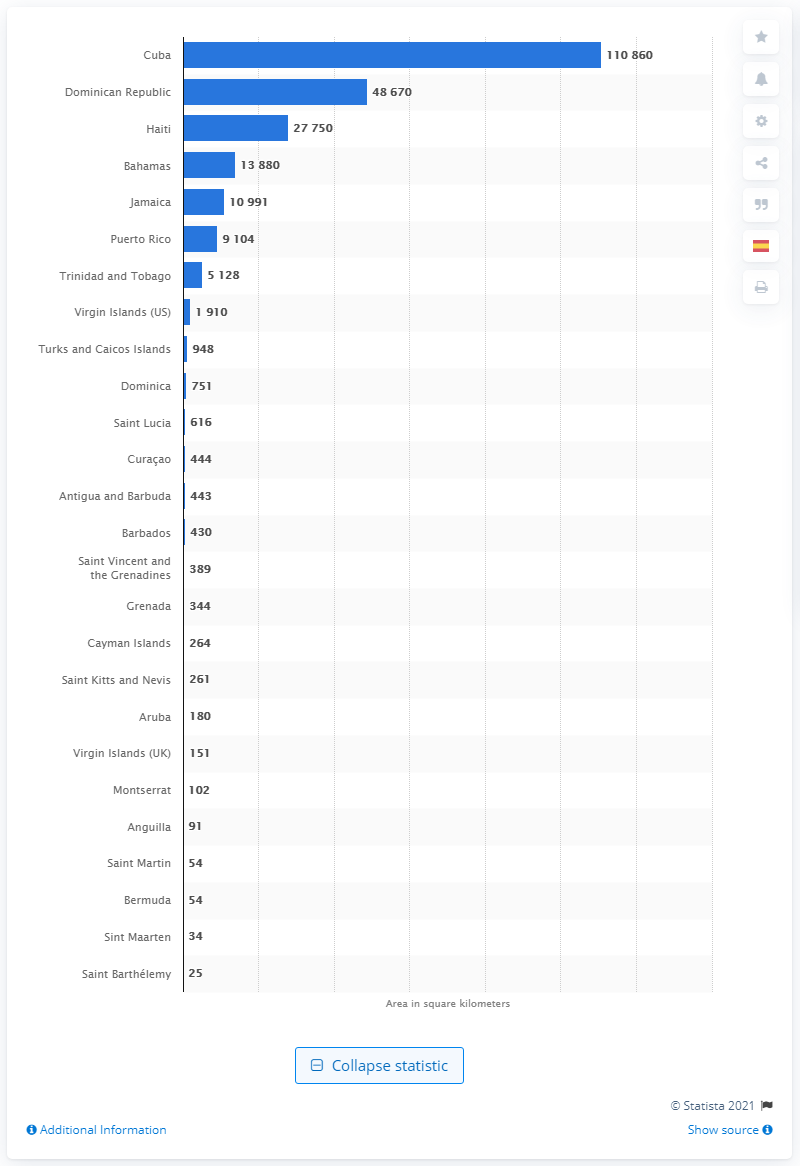Give some essential details in this illustration. The largest island country in the Caribbean Sea is Cuba. 